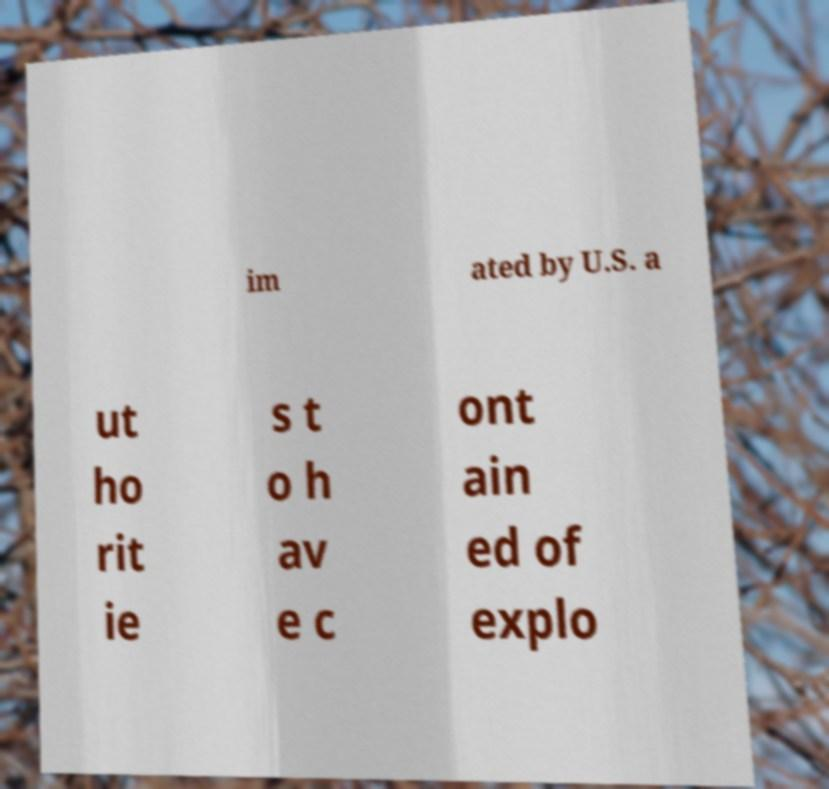What messages or text are displayed in this image? I need them in a readable, typed format. im ated by U.S. a ut ho rit ie s t o h av e c ont ain ed of explo 